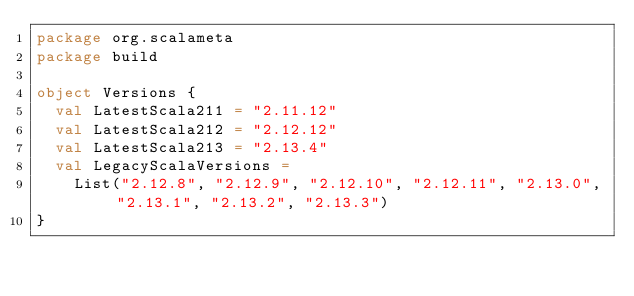<code> <loc_0><loc_0><loc_500><loc_500><_Scala_>package org.scalameta
package build

object Versions {
  val LatestScala211 = "2.11.12"
  val LatestScala212 = "2.12.12"
  val LatestScala213 = "2.13.4"
  val LegacyScalaVersions =
    List("2.12.8", "2.12.9", "2.12.10", "2.12.11", "2.13.0", "2.13.1", "2.13.2", "2.13.3")
}
</code> 